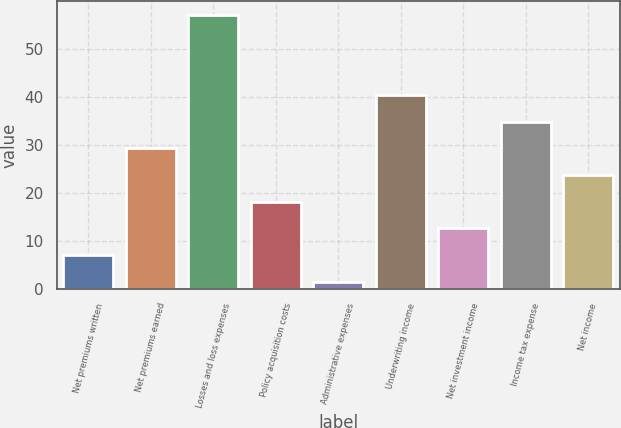<chart> <loc_0><loc_0><loc_500><loc_500><bar_chart><fcel>Net premiums written<fcel>Net premiums earned<fcel>Losses and loss expenses<fcel>Policy acquisition costs<fcel>Administrative expenses<fcel>Underwriting income<fcel>Net investment income<fcel>Income tax expense<fcel>Net income<nl><fcel>7.02<fcel>29.22<fcel>57<fcel>18.12<fcel>1.47<fcel>40.32<fcel>12.57<fcel>34.77<fcel>23.67<nl></chart> 